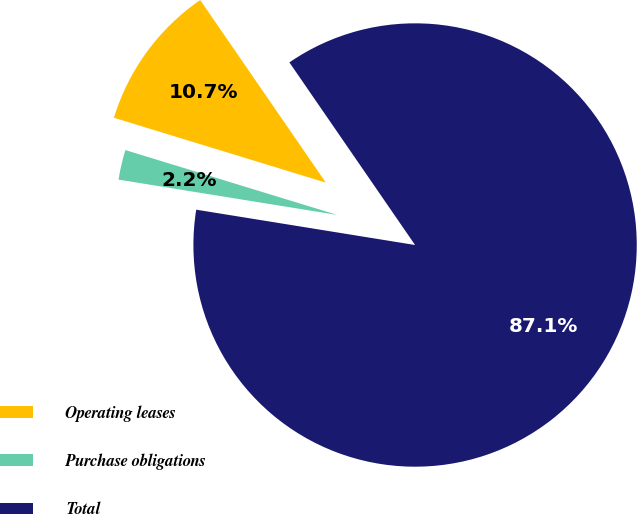Convert chart. <chart><loc_0><loc_0><loc_500><loc_500><pie_chart><fcel>Operating leases<fcel>Purchase obligations<fcel>Total<nl><fcel>10.68%<fcel>2.18%<fcel>87.15%<nl></chart> 